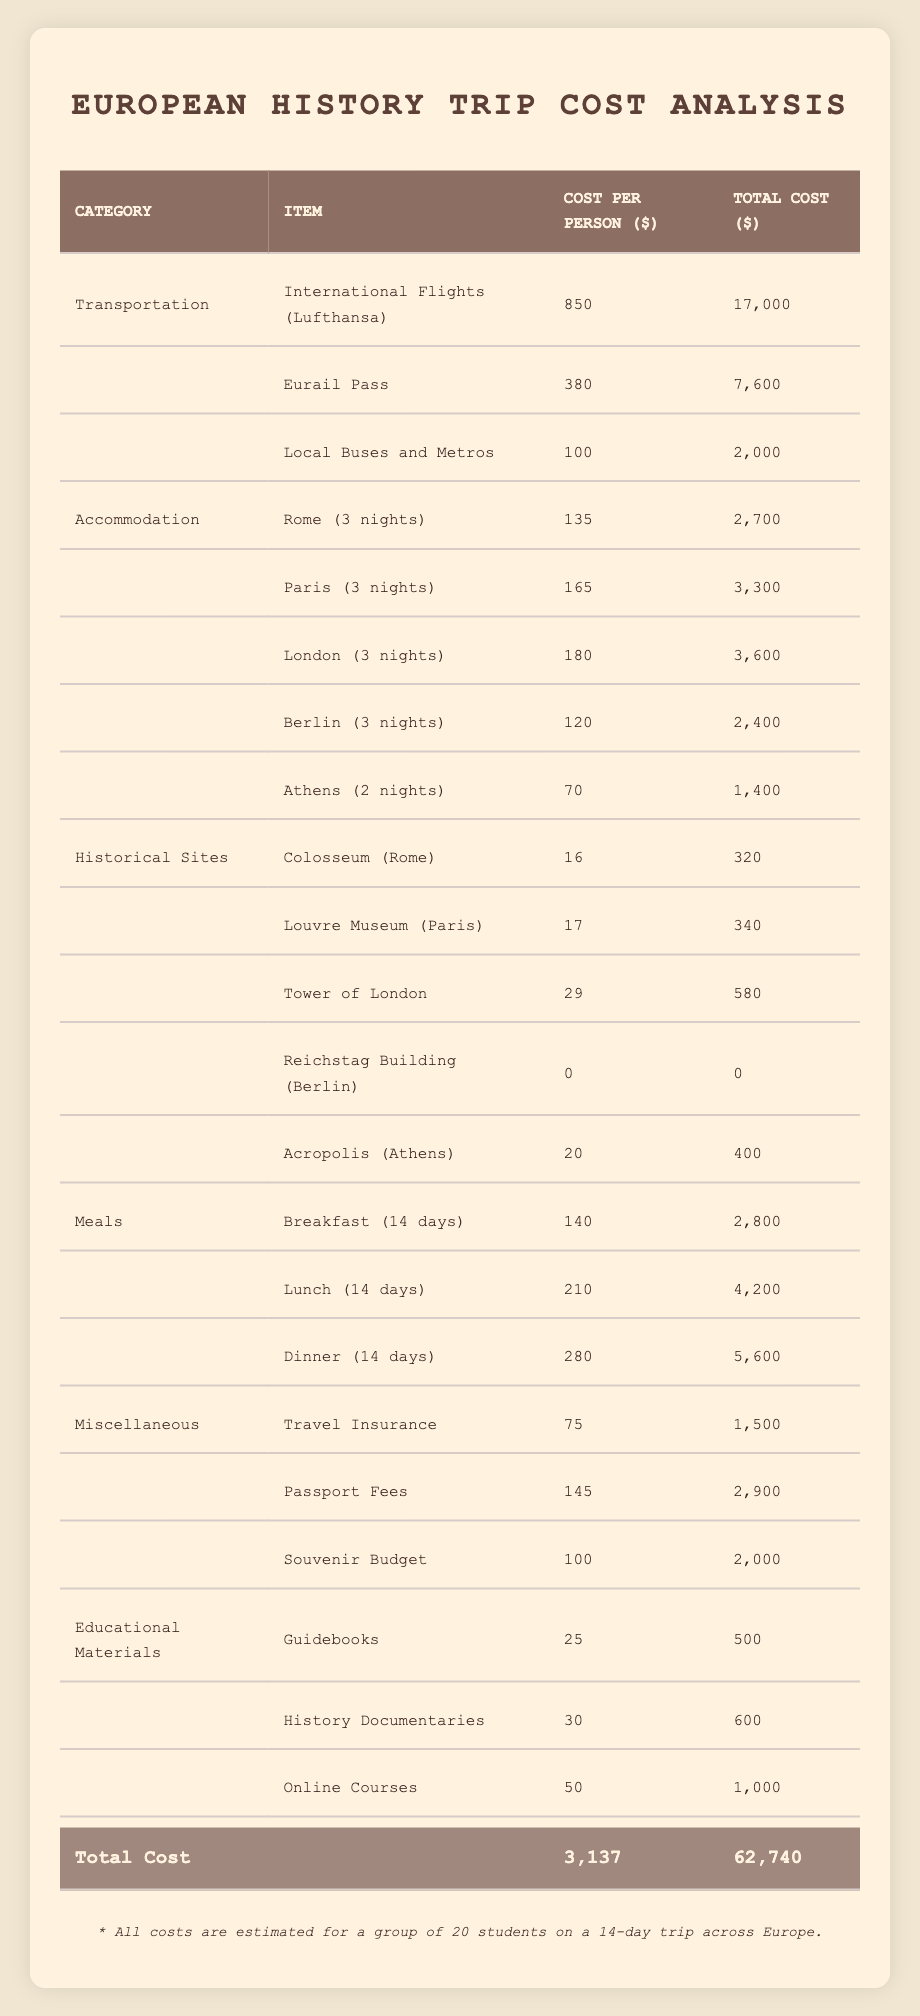What is the total cost for international flights for all students? Each student's cost for international flights is $850. Since there are 20 students, the total cost is calculated as 850 * 20 = 17,000.
Answer: 17,000 What is the total cost for accommodation in London? Students stay in London for 3 nights, with a cost of $60 per night per person. Thus, the total cost for accommodation in London is 60 * 3 * 20 = 3,600.
Answer: 3,600 Are there any entry fees for visiting the Reichstag Building in Berlin? According to the table, the entry fee for the Reichstag Building is $0. This indicates that there are no fees associated with visiting this site.
Answer: Yes What is the average cost per person for meals during the trip? The daily meal costs are divided into breakfast ($10), lunch ($15), and dinner ($20). Thus, the total daily cost for meals is 10 + 15 + 20 = 45. The trip lasts 14 days, so the average cost is 45 * 14 / 14 = 45.
Answer: 45 What is the total cost for entry fees to all historical sites included in the trip? The table shows individual historical site costs: Colosseum ($16), Louvre Museum ($17), Tower of London ($29), Reichstag Building ($0), Acropolis ($20). Adding these gives: 16 + 17 + 29 + 0 + 20 = 82.
Answer: 82 What is the total cost for food and miscellaneous expenses? First, calculate the total food cost: meals are $45 per day for 14 days, which total $630. For miscellaneous expenses: travel insurance ($75), passport fees ($145), and souvenir budget ($100) are added together as 75 + 145 + 100 = 320. Now adding both totals together gives: 630 + 320 = 950.
Answer: 950 Is the total cost for historical site entry fees greater than the total cost for accommodation? The total cost for historical site entry fees is $82, while the total cost for accommodation is $13,400 (2,700 for Rome, 3,300 for Paris, 3,600 for London, 2,400 for Berlin, and 1,400 for Athens). Since 82 is less than 13,400, the statement is false.
Answer: No What is the total estimated cost for the entire trip? The total cost is provided in the last row of the table as $62,740. This figure accounts for all expenses such as transportation, accommodation, meals, historical site entries, miscellaneous expenses, and educational materials.
Answer: 62,740 What will be the total cost for meals per student for the entire trip? The total meal cost per student is $45 per day for 14 days. So, multiplying gives 45 * 14 = 630.
Answer: 630 